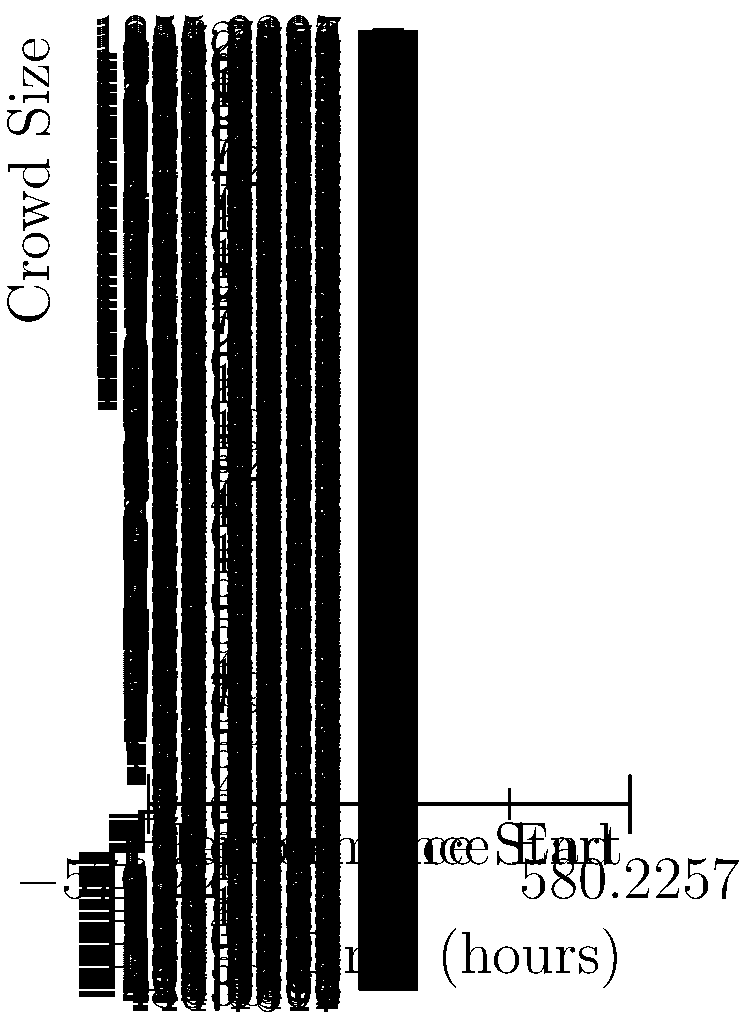The graph shows the crowd size at a club over a 12-hour period, with a performance scheduled from 2 to 10 hours. The crowd size $C(t)$ in number of people at time $t$ in hours is given by the function:

$$C(t) = 1000 + 500\sin(\frac{\pi t}{6})$$

At what time during the performance is the rate of change in crowd size the highest, and what is this maximum rate? To find the time when the rate of change in crowd size is highest during the performance, we need to follow these steps:

1) The rate of change is given by the derivative of $C(t)$. Let's call it $C'(t)$:

   $$C'(t) = 500 \cdot \frac{\pi}{6} \cos(\frac{\pi t}{6})$$

2) The maximum rate of change will occur when $C'(t)$ is at its maximum value during the performance time (2 to 10 hours).

3) $C'(t)$ is maximum when $\cos(\frac{\pi t}{6})$ is at its maximum, which is 1.

4) This occurs when $\frac{\pi t}{6} = 2\pi n$ for integer $n$.

5) Solving for $t$: $t = 12n$

6) The first value of $n$ that puts $t$ in the performance time range is $n=0$, giving $t=0$. But since this is before the performance, we take the next value, $n=1$, giving $t=12$.

7) However, the performance ends at 10 hours. So the maximum rate of change during the performance occurs at the start of the performance, $t=2$.

8) To find the maximum rate, we substitute $t=2$ into $C'(t)$:

   $$C'(2) = 500 \cdot \frac{\pi}{6} \cos(\frac{\pi \cdot 2}{6}) = 500 \cdot \frac{\pi}{6} \cos(\frac{\pi}{3}) = 500 \cdot \frac{\pi}{6} \cdot \frac{1}{2} = \frac{500\pi}{12} \approx 130.9$$

Thus, the maximum rate of change is approximately 131 people per hour, occurring at the start of the performance (2 hours).
Answer: 2 hours, 131 people/hour 